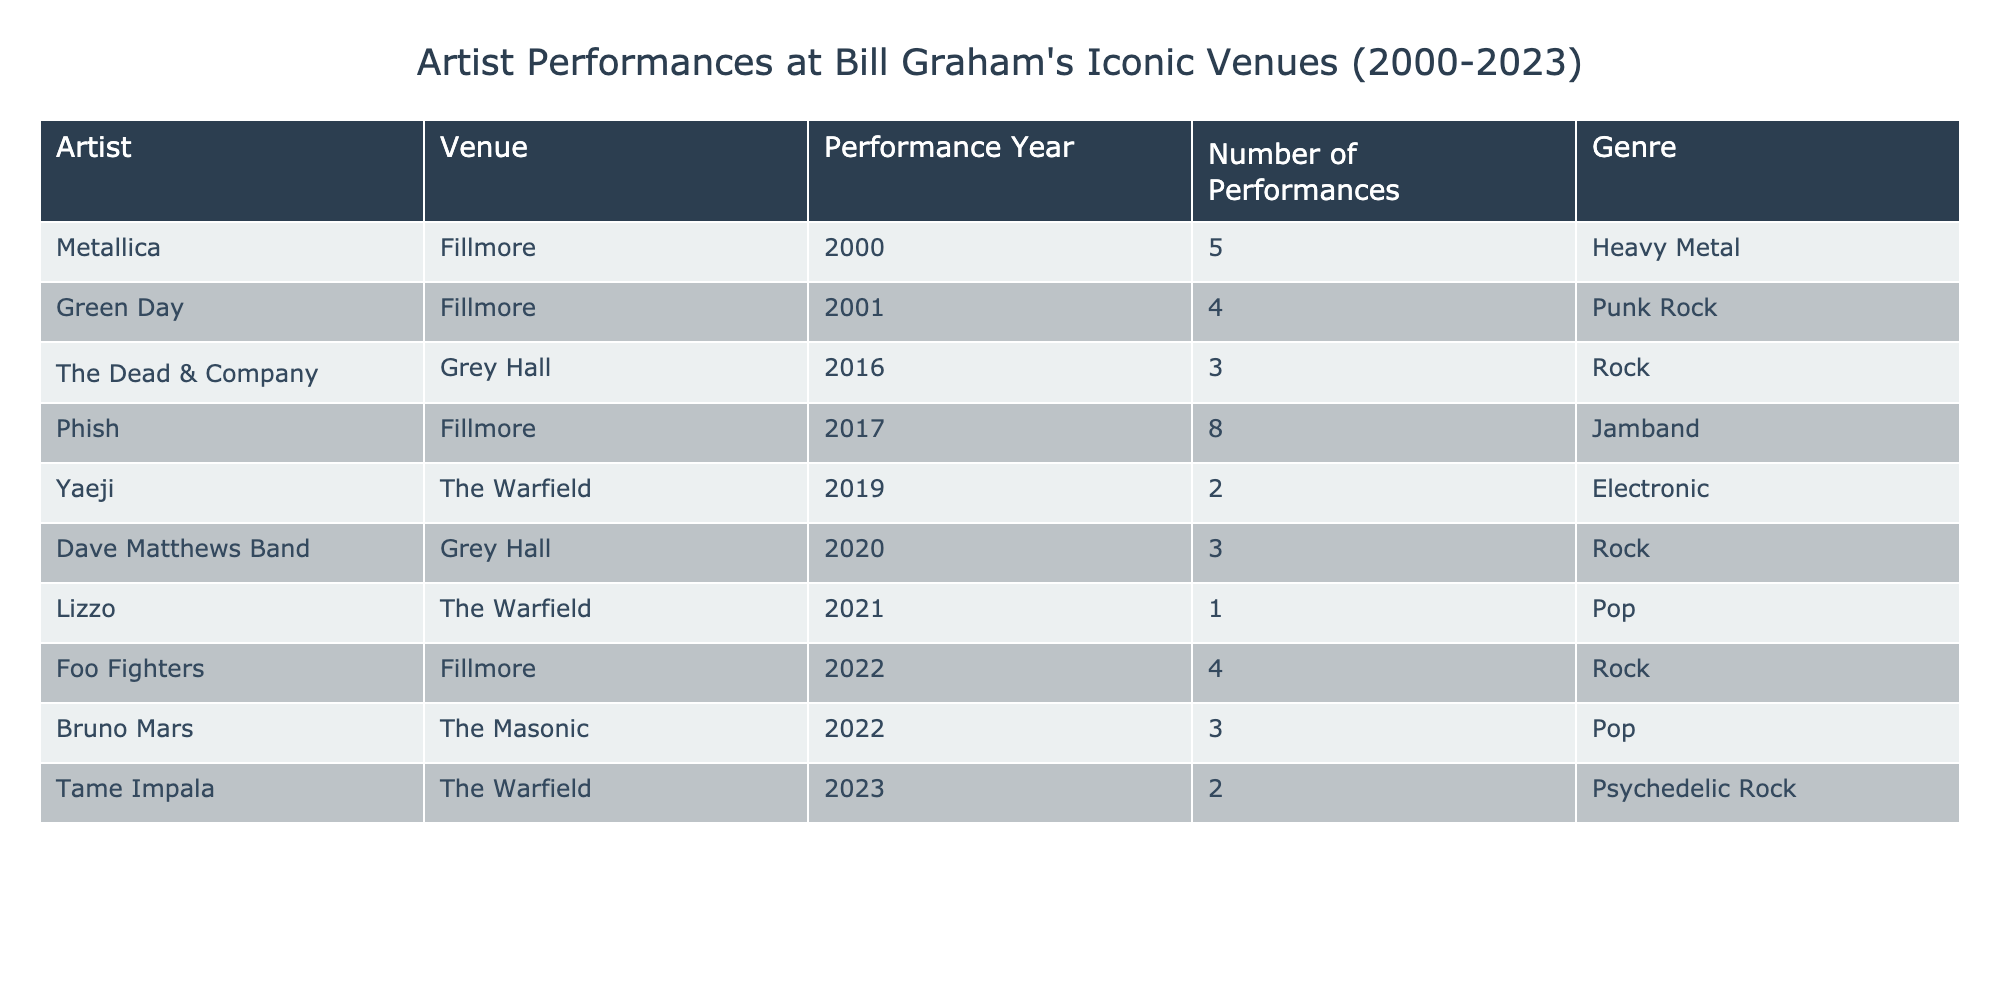What artist performed the most at the Fillmore? By reviewing the "Number of Performances" for each artist at the Fillmore, we see that Metallica performed 5 times and Phish performed 8 times. Therefore, Phish has the highest count among the listed performances at this venue.
Answer: Phish Which venue did Lizzo perform at and in what year? The table shows that Lizzo performed at The Warfield in 2021. This specific information can be easily found in the relevant row of the table.
Answer: The Warfield, 2021 How many total performances did artists have at Grey Hall between 2016 and 2020? To find this total, we look at the "Number of Performances" column for the artists performing at Grey Hall: The Dead & Company (3 performances in 2016) and Dave Matthews Band (3 performances in 2020). Summing these gives us 3 + 3 = 6 performances in total.
Answer: 6 Did any artist perform at The Warfield more than once? We check the "Number of Performances" at The Warfield: Yaeji (2 performances in 2019) and Tame Impala (2 performances in 2023) both performed more than once at this venue, confirming that there are artists who meet this criterion.
Answer: Yes What is the average number of performances for artists at the Fillmore? First, we sum the performances by artists at the Fillmore: Metallica (5), Green Day (4), Phish (8), and Foo Fighters (4), giving us a total of 21 performances. There are 4 data points (artists), so we divide the total by the number of performances: 21/4 = 5.25.
Answer: 5.25 